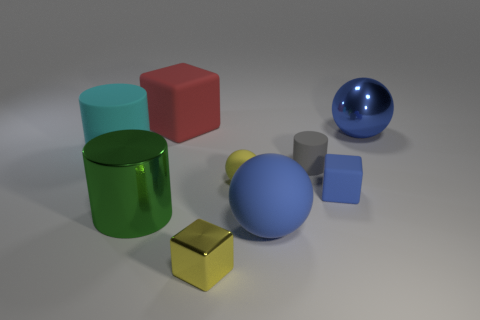Are there any tiny blue cubes that have the same material as the cyan cylinder?
Make the answer very short. Yes. What number of green things are there?
Make the answer very short. 1. Is the material of the small gray thing the same as the big cylinder that is in front of the large cyan cylinder?
Keep it short and to the point. No. What is the material of the thing that is the same color as the small ball?
Make the answer very short. Metal. What number of big objects have the same color as the large shiny sphere?
Provide a short and direct response. 1. What is the size of the cyan thing?
Your answer should be compact. Large. Do the big red matte object and the tiny yellow thing behind the small yellow metallic object have the same shape?
Make the answer very short. No. There is a small block that is made of the same material as the yellow sphere; what is its color?
Provide a succinct answer. Blue. What is the size of the blue matte object right of the small gray rubber object?
Ensure brevity in your answer.  Small. Are there fewer large blue matte things on the left side of the big green metal cylinder than brown matte cubes?
Your answer should be compact. No. 